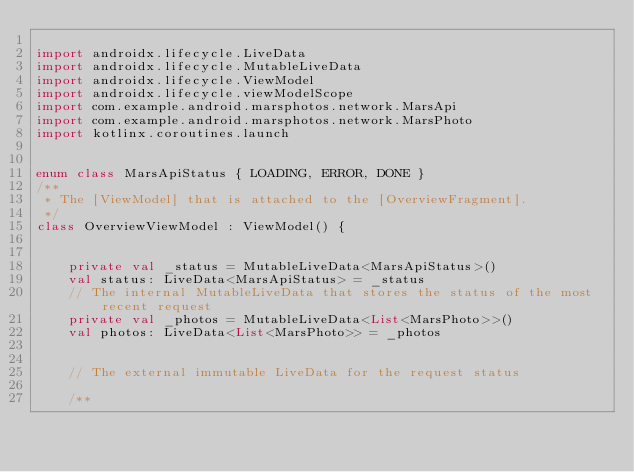<code> <loc_0><loc_0><loc_500><loc_500><_Kotlin_>
import androidx.lifecycle.LiveData
import androidx.lifecycle.MutableLiveData
import androidx.lifecycle.ViewModel
import androidx.lifecycle.viewModelScope
import com.example.android.marsphotos.network.MarsApi
import com.example.android.marsphotos.network.MarsPhoto
import kotlinx.coroutines.launch


enum class MarsApiStatus { LOADING, ERROR, DONE }
/**
 * The [ViewModel] that is attached to the [OverviewFragment].
 */
class OverviewViewModel : ViewModel() {


    private val _status = MutableLiveData<MarsApiStatus>()
    val status: LiveData<MarsApiStatus> = _status
    // The internal MutableLiveData that stores the status of the most recent request
    private val _photos = MutableLiveData<List<MarsPhoto>>()
    val photos: LiveData<List<MarsPhoto>> = _photos


    // The external immutable LiveData for the request status

    /**</code> 